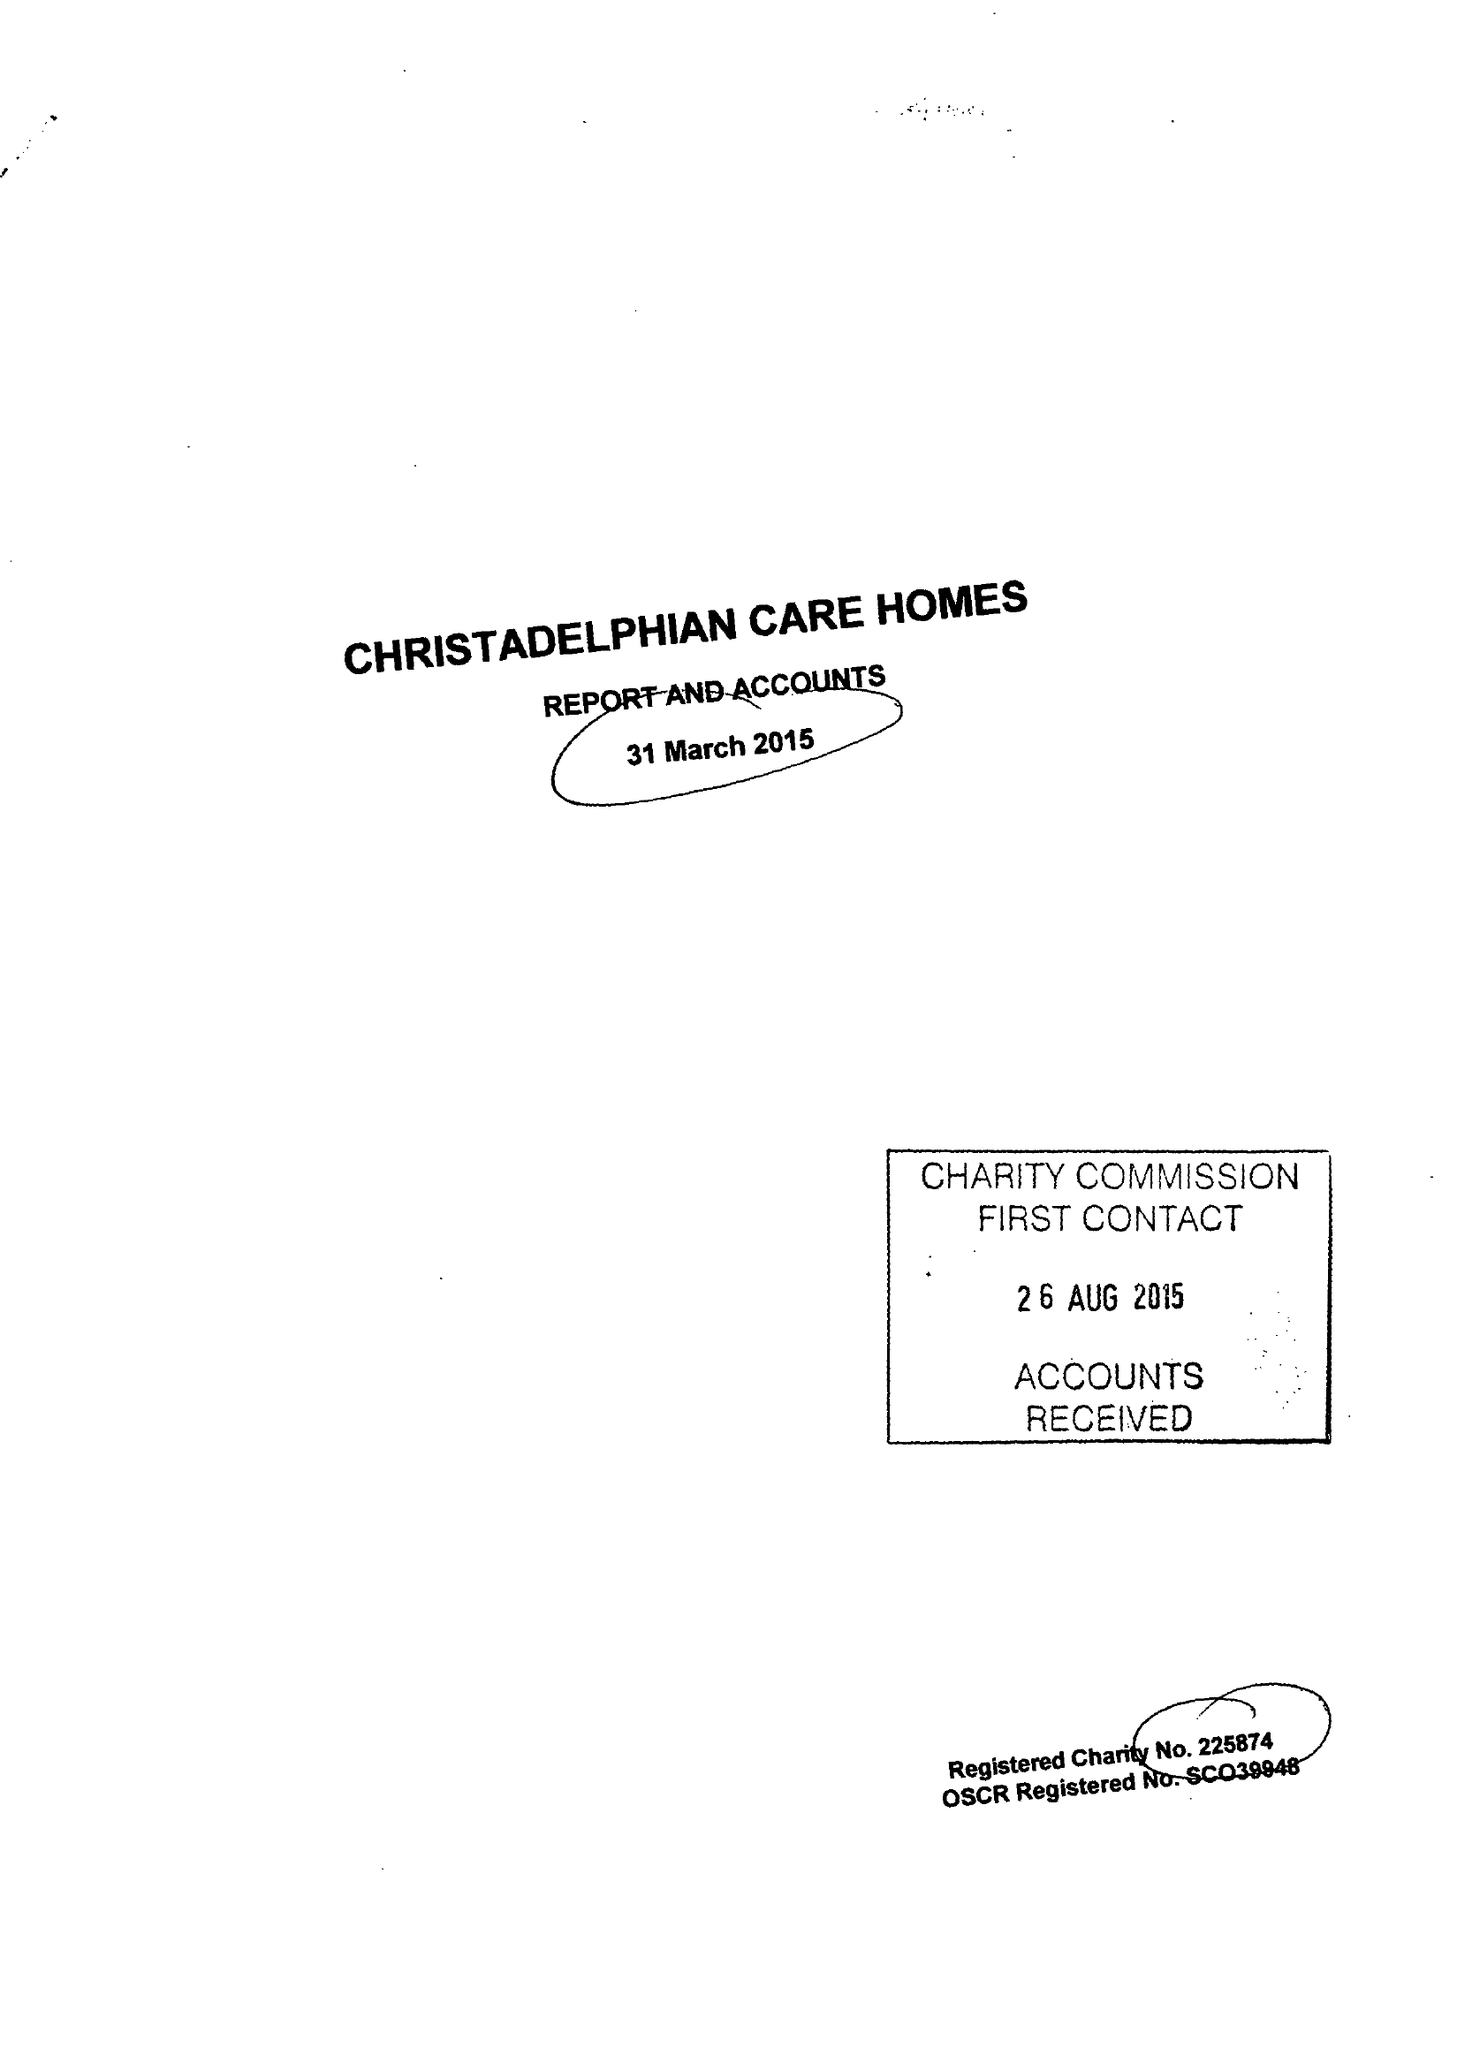What is the value for the address__street_line?
Answer the question using a single word or phrase. 17 SHERBOURNE ROAD 